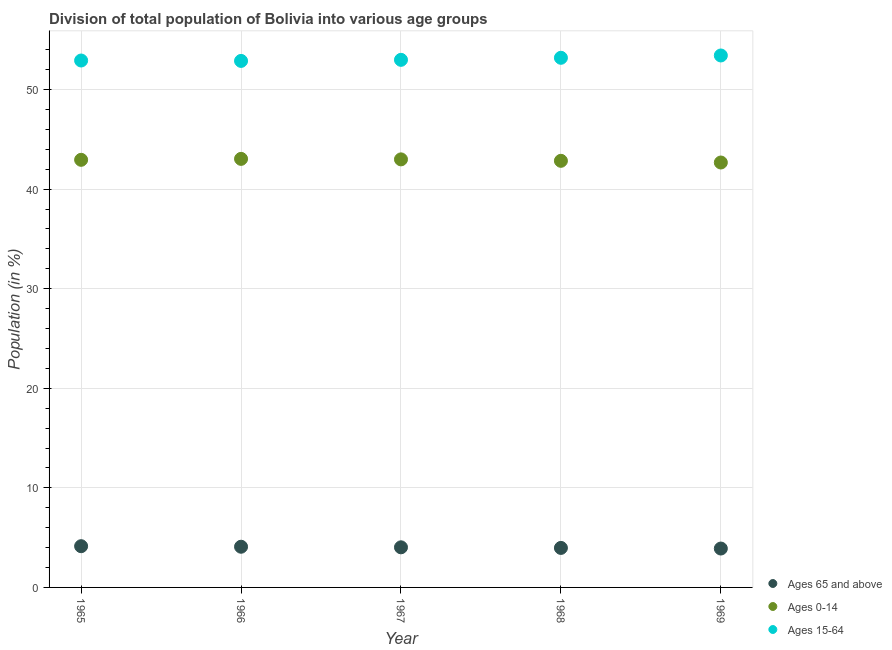How many different coloured dotlines are there?
Offer a very short reply. 3. What is the percentage of population within the age-group of 65 and above in 1966?
Ensure brevity in your answer.  4.09. Across all years, what is the maximum percentage of population within the age-group 15-64?
Provide a short and direct response. 53.42. Across all years, what is the minimum percentage of population within the age-group 15-64?
Your answer should be very brief. 52.88. In which year was the percentage of population within the age-group of 65 and above maximum?
Make the answer very short. 1965. In which year was the percentage of population within the age-group 0-14 minimum?
Your answer should be very brief. 1969. What is the total percentage of population within the age-group of 65 and above in the graph?
Ensure brevity in your answer.  20.13. What is the difference between the percentage of population within the age-group 15-64 in 1965 and that in 1967?
Offer a very short reply. -0.07. What is the difference between the percentage of population within the age-group 15-64 in 1968 and the percentage of population within the age-group 0-14 in 1969?
Offer a very short reply. 10.52. What is the average percentage of population within the age-group 0-14 per year?
Provide a succinct answer. 42.9. In the year 1968, what is the difference between the percentage of population within the age-group of 65 and above and percentage of population within the age-group 0-14?
Provide a succinct answer. -38.88. In how many years, is the percentage of population within the age-group 0-14 greater than 50 %?
Provide a succinct answer. 0. What is the ratio of the percentage of population within the age-group 0-14 in 1965 to that in 1968?
Ensure brevity in your answer.  1. Is the difference between the percentage of population within the age-group of 65 and above in 1965 and 1969 greater than the difference between the percentage of population within the age-group 0-14 in 1965 and 1969?
Your answer should be compact. No. What is the difference between the highest and the second highest percentage of population within the age-group 0-14?
Keep it short and to the point. 0.05. What is the difference between the highest and the lowest percentage of population within the age-group 0-14?
Make the answer very short. 0.37. Is it the case that in every year, the sum of the percentage of population within the age-group of 65 and above and percentage of population within the age-group 0-14 is greater than the percentage of population within the age-group 15-64?
Ensure brevity in your answer.  No. Does the percentage of population within the age-group 15-64 monotonically increase over the years?
Give a very brief answer. No. Is the percentage of population within the age-group 15-64 strictly greater than the percentage of population within the age-group 0-14 over the years?
Your answer should be very brief. Yes. Is the percentage of population within the age-group 15-64 strictly less than the percentage of population within the age-group of 65 and above over the years?
Ensure brevity in your answer.  No. How many years are there in the graph?
Keep it short and to the point. 5. What is the difference between two consecutive major ticks on the Y-axis?
Your answer should be compact. 10. Are the values on the major ticks of Y-axis written in scientific E-notation?
Make the answer very short. No. Does the graph contain any zero values?
Make the answer very short. No. Does the graph contain grids?
Your answer should be very brief. Yes. Where does the legend appear in the graph?
Provide a succinct answer. Bottom right. How many legend labels are there?
Provide a short and direct response. 3. What is the title of the graph?
Keep it short and to the point. Division of total population of Bolivia into various age groups
. Does "Ages 0-14" appear as one of the legend labels in the graph?
Your response must be concise. Yes. What is the Population (in %) of Ages 65 and above in 1965?
Make the answer very short. 4.14. What is the Population (in %) in Ages 0-14 in 1965?
Keep it short and to the point. 42.94. What is the Population (in %) of Ages 15-64 in 1965?
Your answer should be very brief. 52.92. What is the Population (in %) in Ages 65 and above in 1966?
Your response must be concise. 4.09. What is the Population (in %) of Ages 0-14 in 1966?
Provide a short and direct response. 43.04. What is the Population (in %) of Ages 15-64 in 1966?
Provide a succinct answer. 52.88. What is the Population (in %) of Ages 65 and above in 1967?
Keep it short and to the point. 4.03. What is the Population (in %) of Ages 0-14 in 1967?
Provide a short and direct response. 42.99. What is the Population (in %) of Ages 15-64 in 1967?
Keep it short and to the point. 52.98. What is the Population (in %) of Ages 65 and above in 1968?
Your answer should be very brief. 3.97. What is the Population (in %) of Ages 0-14 in 1968?
Give a very brief answer. 42.84. What is the Population (in %) of Ages 15-64 in 1968?
Provide a succinct answer. 53.19. What is the Population (in %) in Ages 65 and above in 1969?
Keep it short and to the point. 3.91. What is the Population (in %) in Ages 0-14 in 1969?
Provide a succinct answer. 42.67. What is the Population (in %) of Ages 15-64 in 1969?
Keep it short and to the point. 53.42. Across all years, what is the maximum Population (in %) of Ages 65 and above?
Provide a short and direct response. 4.14. Across all years, what is the maximum Population (in %) of Ages 0-14?
Your response must be concise. 43.04. Across all years, what is the maximum Population (in %) of Ages 15-64?
Keep it short and to the point. 53.42. Across all years, what is the minimum Population (in %) in Ages 65 and above?
Offer a very short reply. 3.91. Across all years, what is the minimum Population (in %) in Ages 0-14?
Ensure brevity in your answer.  42.67. Across all years, what is the minimum Population (in %) in Ages 15-64?
Keep it short and to the point. 52.88. What is the total Population (in %) of Ages 65 and above in the graph?
Your answer should be very brief. 20.13. What is the total Population (in %) in Ages 0-14 in the graph?
Keep it short and to the point. 214.49. What is the total Population (in %) in Ages 15-64 in the graph?
Provide a short and direct response. 265.39. What is the difference between the Population (in %) of Ages 65 and above in 1965 and that in 1966?
Offer a terse response. 0.05. What is the difference between the Population (in %) of Ages 0-14 in 1965 and that in 1966?
Provide a short and direct response. -0.1. What is the difference between the Population (in %) of Ages 15-64 in 1965 and that in 1966?
Offer a terse response. 0.04. What is the difference between the Population (in %) of Ages 65 and above in 1965 and that in 1967?
Give a very brief answer. 0.11. What is the difference between the Population (in %) of Ages 0-14 in 1965 and that in 1967?
Your answer should be compact. -0.05. What is the difference between the Population (in %) in Ages 15-64 in 1965 and that in 1967?
Offer a terse response. -0.07. What is the difference between the Population (in %) of Ages 65 and above in 1965 and that in 1968?
Your response must be concise. 0.17. What is the difference between the Population (in %) in Ages 0-14 in 1965 and that in 1968?
Offer a very short reply. 0.1. What is the difference between the Population (in %) of Ages 15-64 in 1965 and that in 1968?
Provide a short and direct response. -0.27. What is the difference between the Population (in %) of Ages 65 and above in 1965 and that in 1969?
Offer a very short reply. 0.24. What is the difference between the Population (in %) of Ages 0-14 in 1965 and that in 1969?
Keep it short and to the point. 0.27. What is the difference between the Population (in %) of Ages 15-64 in 1965 and that in 1969?
Provide a succinct answer. -0.51. What is the difference between the Population (in %) of Ages 65 and above in 1966 and that in 1967?
Keep it short and to the point. 0.06. What is the difference between the Population (in %) of Ages 0-14 in 1966 and that in 1967?
Keep it short and to the point. 0.05. What is the difference between the Population (in %) in Ages 15-64 in 1966 and that in 1967?
Your answer should be compact. -0.11. What is the difference between the Population (in %) of Ages 65 and above in 1966 and that in 1968?
Your answer should be compact. 0.12. What is the difference between the Population (in %) of Ages 0-14 in 1966 and that in 1968?
Ensure brevity in your answer.  0.2. What is the difference between the Population (in %) in Ages 15-64 in 1966 and that in 1968?
Provide a succinct answer. -0.31. What is the difference between the Population (in %) in Ages 65 and above in 1966 and that in 1969?
Your response must be concise. 0.18. What is the difference between the Population (in %) in Ages 0-14 in 1966 and that in 1969?
Offer a terse response. 0.36. What is the difference between the Population (in %) of Ages 15-64 in 1966 and that in 1969?
Provide a succinct answer. -0.55. What is the difference between the Population (in %) in Ages 65 and above in 1967 and that in 1968?
Give a very brief answer. 0.06. What is the difference between the Population (in %) in Ages 0-14 in 1967 and that in 1968?
Your answer should be very brief. 0.15. What is the difference between the Population (in %) in Ages 15-64 in 1967 and that in 1968?
Give a very brief answer. -0.21. What is the difference between the Population (in %) of Ages 65 and above in 1967 and that in 1969?
Your answer should be compact. 0.12. What is the difference between the Population (in %) in Ages 0-14 in 1967 and that in 1969?
Your answer should be compact. 0.32. What is the difference between the Population (in %) in Ages 15-64 in 1967 and that in 1969?
Offer a very short reply. -0.44. What is the difference between the Population (in %) of Ages 65 and above in 1968 and that in 1969?
Offer a terse response. 0.06. What is the difference between the Population (in %) of Ages 0-14 in 1968 and that in 1969?
Offer a very short reply. 0.17. What is the difference between the Population (in %) in Ages 15-64 in 1968 and that in 1969?
Provide a succinct answer. -0.23. What is the difference between the Population (in %) in Ages 65 and above in 1965 and the Population (in %) in Ages 0-14 in 1966?
Offer a terse response. -38.9. What is the difference between the Population (in %) in Ages 65 and above in 1965 and the Population (in %) in Ages 15-64 in 1966?
Ensure brevity in your answer.  -48.73. What is the difference between the Population (in %) in Ages 0-14 in 1965 and the Population (in %) in Ages 15-64 in 1966?
Make the answer very short. -9.93. What is the difference between the Population (in %) of Ages 65 and above in 1965 and the Population (in %) of Ages 0-14 in 1967?
Ensure brevity in your answer.  -38.85. What is the difference between the Population (in %) in Ages 65 and above in 1965 and the Population (in %) in Ages 15-64 in 1967?
Offer a terse response. -48.84. What is the difference between the Population (in %) in Ages 0-14 in 1965 and the Population (in %) in Ages 15-64 in 1967?
Give a very brief answer. -10.04. What is the difference between the Population (in %) of Ages 65 and above in 1965 and the Population (in %) of Ages 0-14 in 1968?
Ensure brevity in your answer.  -38.7. What is the difference between the Population (in %) in Ages 65 and above in 1965 and the Population (in %) in Ages 15-64 in 1968?
Provide a succinct answer. -49.05. What is the difference between the Population (in %) of Ages 0-14 in 1965 and the Population (in %) of Ages 15-64 in 1968?
Your response must be concise. -10.25. What is the difference between the Population (in %) in Ages 65 and above in 1965 and the Population (in %) in Ages 0-14 in 1969?
Offer a terse response. -38.53. What is the difference between the Population (in %) of Ages 65 and above in 1965 and the Population (in %) of Ages 15-64 in 1969?
Ensure brevity in your answer.  -49.28. What is the difference between the Population (in %) in Ages 0-14 in 1965 and the Population (in %) in Ages 15-64 in 1969?
Offer a very short reply. -10.48. What is the difference between the Population (in %) of Ages 65 and above in 1966 and the Population (in %) of Ages 0-14 in 1967?
Your response must be concise. -38.9. What is the difference between the Population (in %) in Ages 65 and above in 1966 and the Population (in %) in Ages 15-64 in 1967?
Provide a succinct answer. -48.9. What is the difference between the Population (in %) in Ages 0-14 in 1966 and the Population (in %) in Ages 15-64 in 1967?
Your answer should be very brief. -9.95. What is the difference between the Population (in %) of Ages 65 and above in 1966 and the Population (in %) of Ages 0-14 in 1968?
Keep it short and to the point. -38.76. What is the difference between the Population (in %) of Ages 65 and above in 1966 and the Population (in %) of Ages 15-64 in 1968?
Make the answer very short. -49.1. What is the difference between the Population (in %) in Ages 0-14 in 1966 and the Population (in %) in Ages 15-64 in 1968?
Provide a succinct answer. -10.15. What is the difference between the Population (in %) in Ages 65 and above in 1966 and the Population (in %) in Ages 0-14 in 1969?
Offer a very short reply. -38.59. What is the difference between the Population (in %) in Ages 65 and above in 1966 and the Population (in %) in Ages 15-64 in 1969?
Keep it short and to the point. -49.34. What is the difference between the Population (in %) of Ages 0-14 in 1966 and the Population (in %) of Ages 15-64 in 1969?
Offer a very short reply. -10.38. What is the difference between the Population (in %) of Ages 65 and above in 1967 and the Population (in %) of Ages 0-14 in 1968?
Your answer should be compact. -38.81. What is the difference between the Population (in %) of Ages 65 and above in 1967 and the Population (in %) of Ages 15-64 in 1968?
Keep it short and to the point. -49.16. What is the difference between the Population (in %) of Ages 0-14 in 1967 and the Population (in %) of Ages 15-64 in 1968?
Offer a very short reply. -10.2. What is the difference between the Population (in %) in Ages 65 and above in 1967 and the Population (in %) in Ages 0-14 in 1969?
Ensure brevity in your answer.  -38.64. What is the difference between the Population (in %) of Ages 65 and above in 1967 and the Population (in %) of Ages 15-64 in 1969?
Provide a succinct answer. -49.39. What is the difference between the Population (in %) of Ages 0-14 in 1967 and the Population (in %) of Ages 15-64 in 1969?
Ensure brevity in your answer.  -10.43. What is the difference between the Population (in %) of Ages 65 and above in 1968 and the Population (in %) of Ages 0-14 in 1969?
Offer a terse response. -38.71. What is the difference between the Population (in %) of Ages 65 and above in 1968 and the Population (in %) of Ages 15-64 in 1969?
Give a very brief answer. -49.45. What is the difference between the Population (in %) of Ages 0-14 in 1968 and the Population (in %) of Ages 15-64 in 1969?
Your answer should be very brief. -10.58. What is the average Population (in %) of Ages 65 and above per year?
Offer a very short reply. 4.03. What is the average Population (in %) in Ages 0-14 per year?
Offer a terse response. 42.9. What is the average Population (in %) of Ages 15-64 per year?
Provide a succinct answer. 53.08. In the year 1965, what is the difference between the Population (in %) in Ages 65 and above and Population (in %) in Ages 0-14?
Your answer should be compact. -38.8. In the year 1965, what is the difference between the Population (in %) of Ages 65 and above and Population (in %) of Ages 15-64?
Provide a short and direct response. -48.77. In the year 1965, what is the difference between the Population (in %) in Ages 0-14 and Population (in %) in Ages 15-64?
Keep it short and to the point. -9.97. In the year 1966, what is the difference between the Population (in %) of Ages 65 and above and Population (in %) of Ages 0-14?
Make the answer very short. -38.95. In the year 1966, what is the difference between the Population (in %) of Ages 65 and above and Population (in %) of Ages 15-64?
Provide a short and direct response. -48.79. In the year 1966, what is the difference between the Population (in %) of Ages 0-14 and Population (in %) of Ages 15-64?
Make the answer very short. -9.84. In the year 1967, what is the difference between the Population (in %) of Ages 65 and above and Population (in %) of Ages 0-14?
Provide a short and direct response. -38.96. In the year 1967, what is the difference between the Population (in %) of Ages 65 and above and Population (in %) of Ages 15-64?
Make the answer very short. -48.96. In the year 1967, what is the difference between the Population (in %) of Ages 0-14 and Population (in %) of Ages 15-64?
Provide a short and direct response. -10. In the year 1968, what is the difference between the Population (in %) in Ages 65 and above and Population (in %) in Ages 0-14?
Your answer should be very brief. -38.88. In the year 1968, what is the difference between the Population (in %) in Ages 65 and above and Population (in %) in Ages 15-64?
Provide a short and direct response. -49.22. In the year 1968, what is the difference between the Population (in %) in Ages 0-14 and Population (in %) in Ages 15-64?
Ensure brevity in your answer.  -10.35. In the year 1969, what is the difference between the Population (in %) in Ages 65 and above and Population (in %) in Ages 0-14?
Keep it short and to the point. -38.77. In the year 1969, what is the difference between the Population (in %) of Ages 65 and above and Population (in %) of Ages 15-64?
Ensure brevity in your answer.  -49.52. In the year 1969, what is the difference between the Population (in %) in Ages 0-14 and Population (in %) in Ages 15-64?
Your answer should be very brief. -10.75. What is the ratio of the Population (in %) in Ages 65 and above in 1965 to that in 1966?
Offer a terse response. 1.01. What is the ratio of the Population (in %) of Ages 0-14 in 1965 to that in 1966?
Your answer should be very brief. 1. What is the ratio of the Population (in %) in Ages 65 and above in 1965 to that in 1967?
Your answer should be compact. 1.03. What is the ratio of the Population (in %) of Ages 65 and above in 1965 to that in 1968?
Make the answer very short. 1.04. What is the ratio of the Population (in %) in Ages 0-14 in 1965 to that in 1968?
Offer a very short reply. 1. What is the ratio of the Population (in %) of Ages 65 and above in 1965 to that in 1969?
Ensure brevity in your answer.  1.06. What is the ratio of the Population (in %) of Ages 65 and above in 1966 to that in 1967?
Your answer should be compact. 1.01. What is the ratio of the Population (in %) in Ages 0-14 in 1966 to that in 1967?
Offer a terse response. 1. What is the ratio of the Population (in %) of Ages 65 and above in 1966 to that in 1968?
Provide a succinct answer. 1.03. What is the ratio of the Population (in %) in Ages 65 and above in 1966 to that in 1969?
Provide a short and direct response. 1.05. What is the ratio of the Population (in %) of Ages 0-14 in 1966 to that in 1969?
Ensure brevity in your answer.  1.01. What is the ratio of the Population (in %) in Ages 15-64 in 1966 to that in 1969?
Provide a succinct answer. 0.99. What is the ratio of the Population (in %) of Ages 65 and above in 1967 to that in 1968?
Your answer should be compact. 1.02. What is the ratio of the Population (in %) of Ages 0-14 in 1967 to that in 1968?
Your answer should be very brief. 1. What is the ratio of the Population (in %) of Ages 65 and above in 1967 to that in 1969?
Your answer should be compact. 1.03. What is the ratio of the Population (in %) in Ages 0-14 in 1967 to that in 1969?
Ensure brevity in your answer.  1.01. What is the ratio of the Population (in %) in Ages 0-14 in 1968 to that in 1969?
Make the answer very short. 1. What is the difference between the highest and the second highest Population (in %) of Ages 65 and above?
Offer a very short reply. 0.05. What is the difference between the highest and the second highest Population (in %) of Ages 0-14?
Your answer should be very brief. 0.05. What is the difference between the highest and the second highest Population (in %) in Ages 15-64?
Provide a succinct answer. 0.23. What is the difference between the highest and the lowest Population (in %) of Ages 65 and above?
Make the answer very short. 0.24. What is the difference between the highest and the lowest Population (in %) in Ages 0-14?
Your answer should be compact. 0.36. What is the difference between the highest and the lowest Population (in %) in Ages 15-64?
Ensure brevity in your answer.  0.55. 